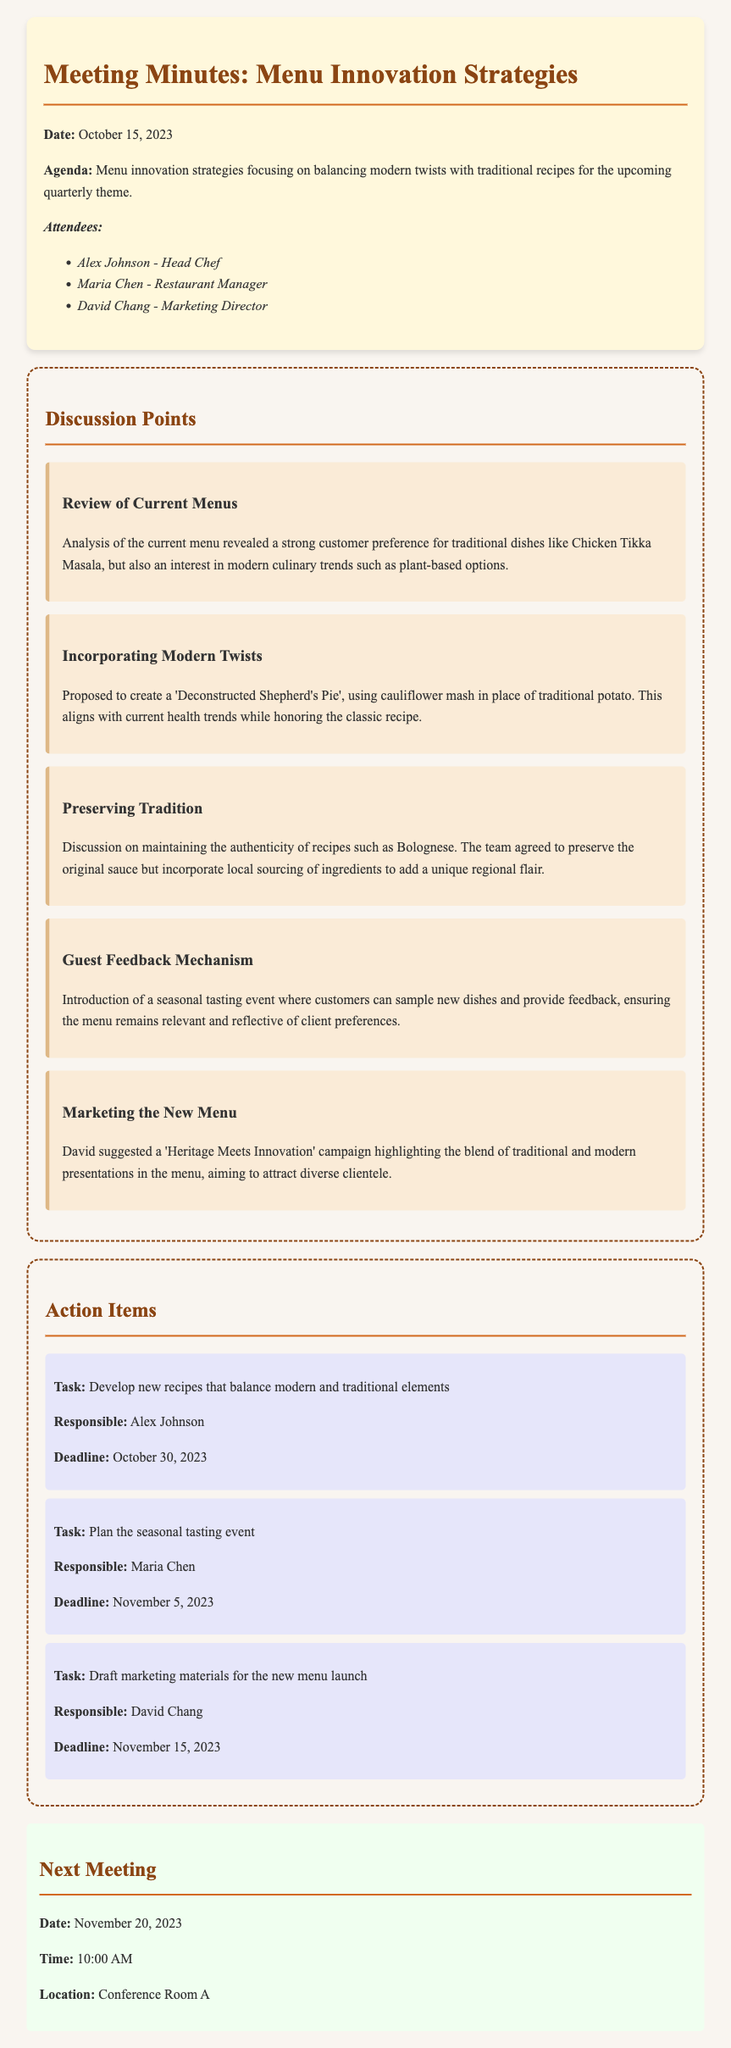What is the date of the meeting? The date of the meeting is clearly mentioned at the beginning of the document as October 15, 2023.
Answer: October 15, 2023 Who is responsible for developing new recipes? The document lists the action items, and Alex Johnson is assigned the task of developing new recipes.
Answer: Alex Johnson What is the focus of the upcoming quarterly theme? The agenda clearly states the focus of the meeting is on menu innovation strategies with an emphasis on balancing modern twists with traditional recipes.
Answer: Balancing modern twists with traditional recipes What is the suggestion for a new dish? The discussion point regarding modern twists suggests creating a 'Deconstructed Shepherd's Pie'.
Answer: Deconstructed Shepherd's Pie When is the next meeting scheduled? The document specifies the date for the next meeting as November 20, 2023.
Answer: November 20, 2023 What unique sourcing idea was discussed for traditional recipes? The discussion on preserving tradition mentions incorporating local sourcing of ingredients to add a regional flair.
Answer: Local sourcing of ingredients Which campaign was proposed for marketing? The marketing discussion suggests a campaign named 'Heritage Meets Innovation' to highlight the menu blend.
Answer: Heritage Meets Innovation What is the deadline for planning the seasonal tasting event? The action item for planning the tasting event includes a deadline of November 5, 2023.
Answer: November 5, 2023 